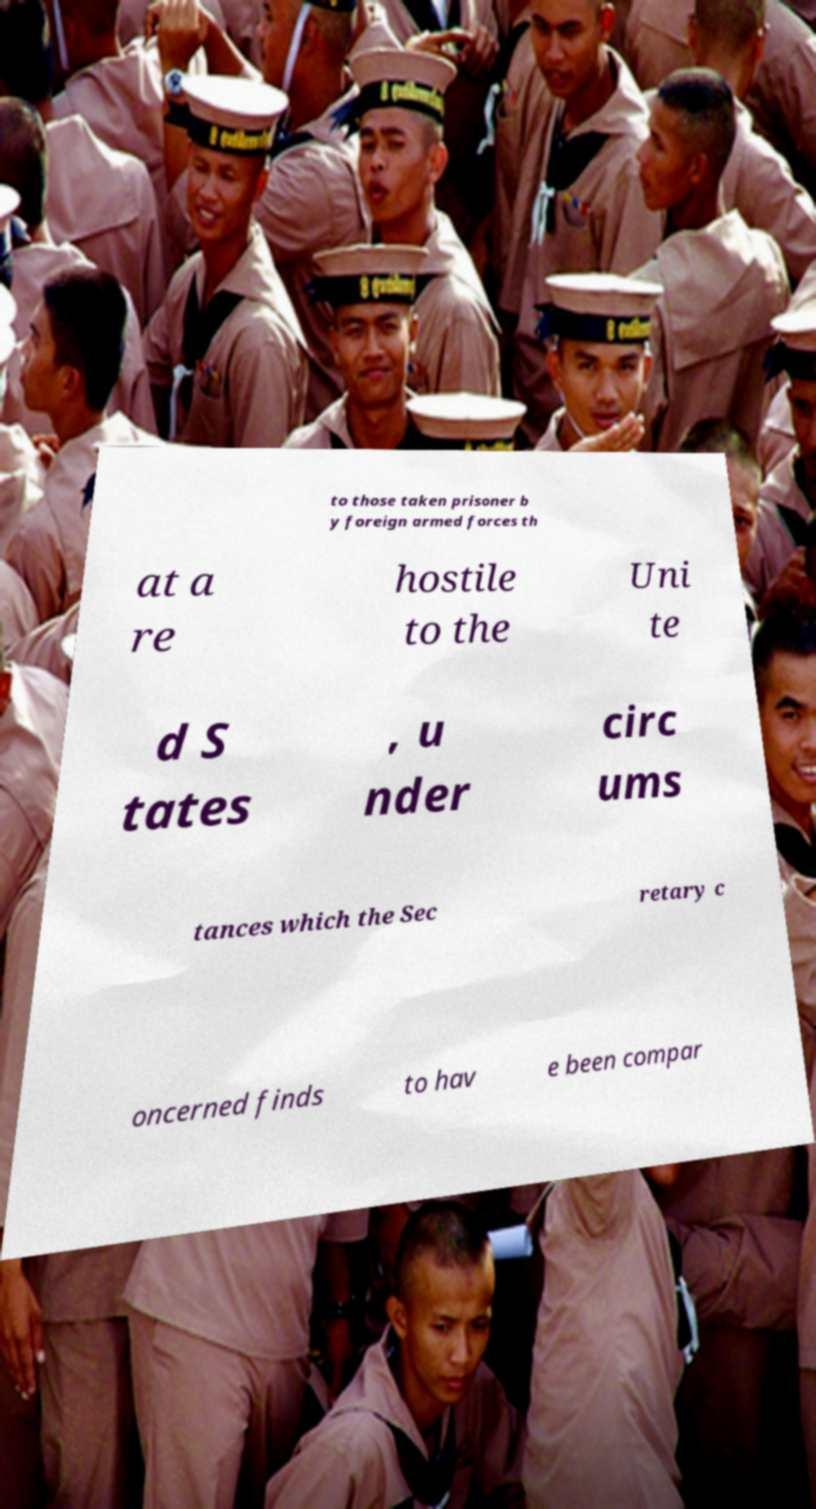There's text embedded in this image that I need extracted. Can you transcribe it verbatim? to those taken prisoner b y foreign armed forces th at a re hostile to the Uni te d S tates , u nder circ ums tances which the Sec retary c oncerned finds to hav e been compar 